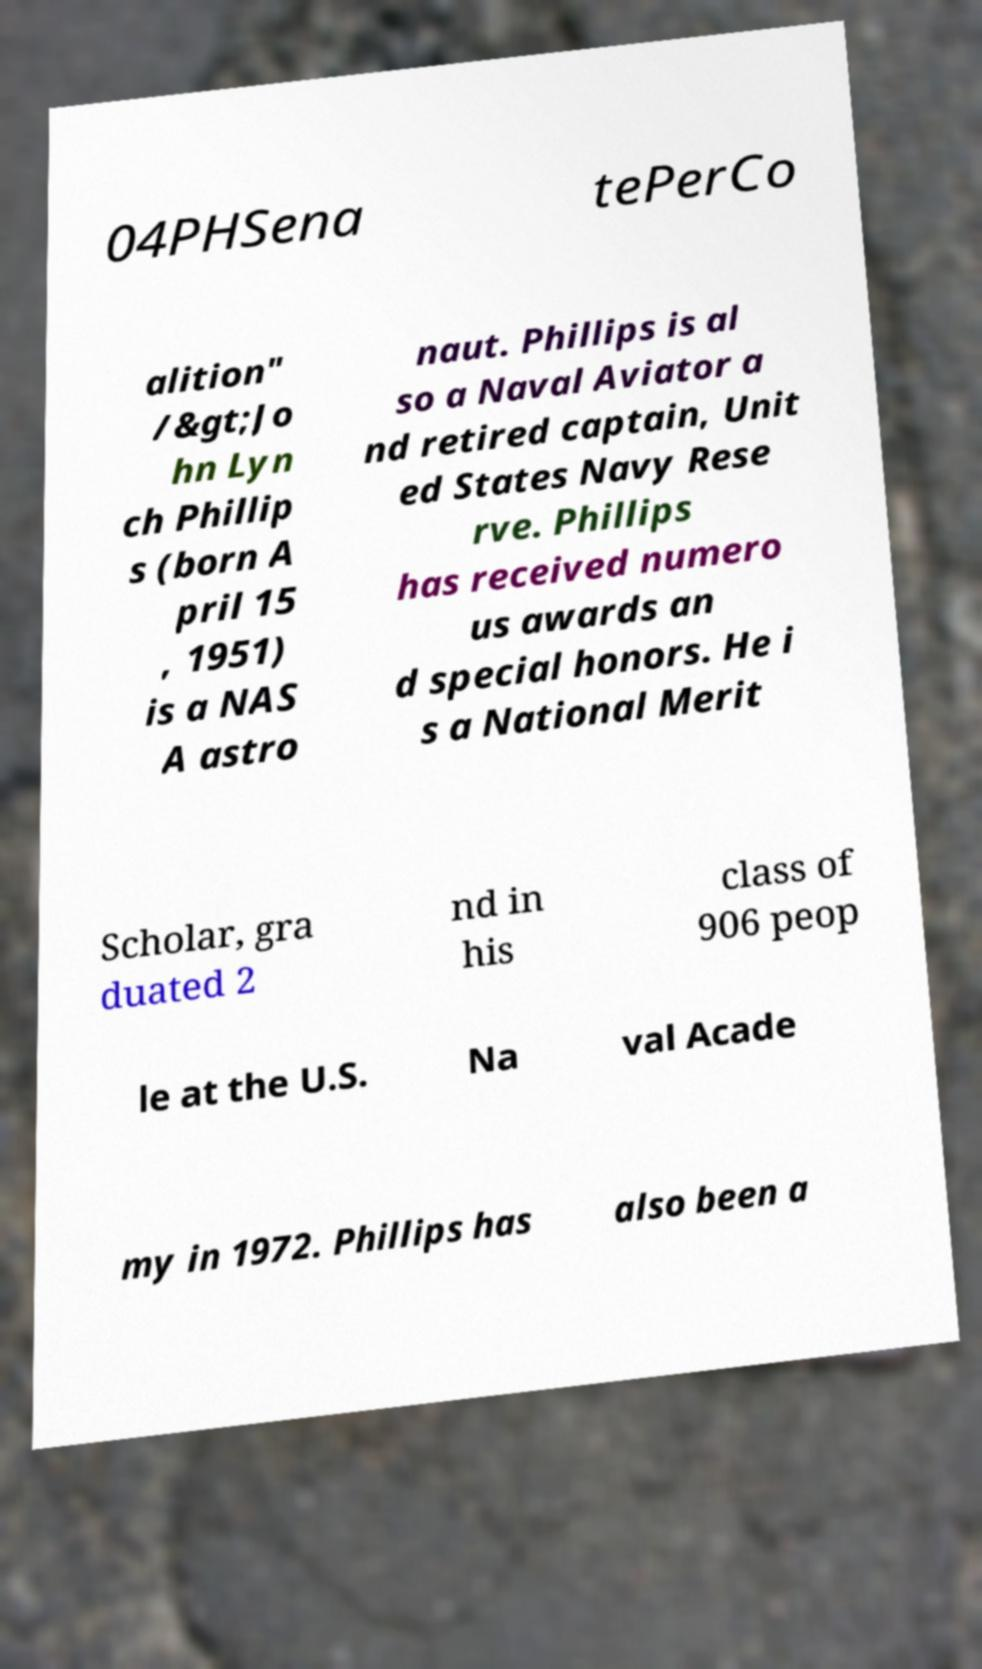Could you assist in decoding the text presented in this image and type it out clearly? 04PHSena tePerCo alition" /&gt;Jo hn Lyn ch Phillip s (born A pril 15 , 1951) is a NAS A astro naut. Phillips is al so a Naval Aviator a nd retired captain, Unit ed States Navy Rese rve. Phillips has received numero us awards an d special honors. He i s a National Merit Scholar, gra duated 2 nd in his class of 906 peop le at the U.S. Na val Acade my in 1972. Phillips has also been a 